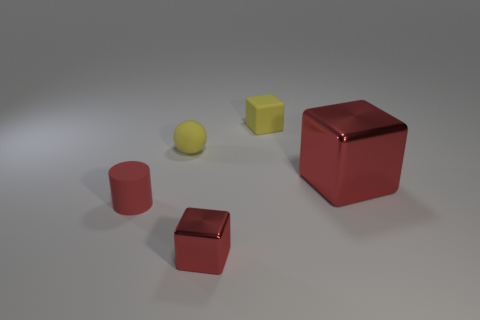Are there any cubes of the same color as the small matte cylinder? Yes, there are cubes that match the color of the small matte cylinder. Specifically, the smaller cube and the larger cube both share the same deep red hue as the cylinder. 